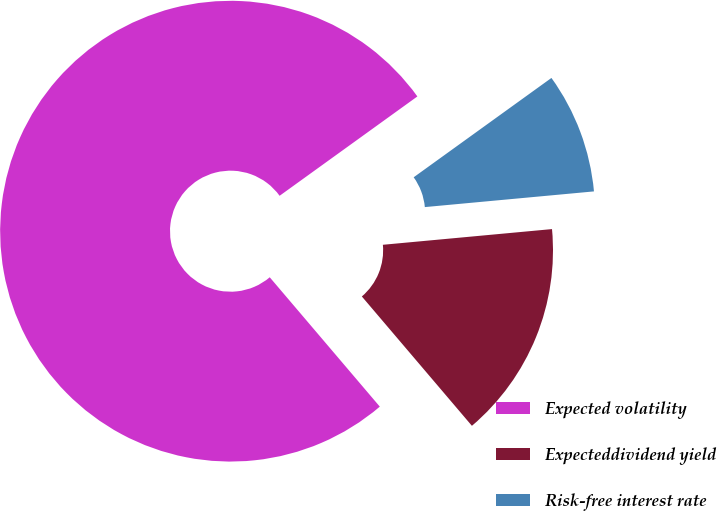Convert chart to OTSL. <chart><loc_0><loc_0><loc_500><loc_500><pie_chart><fcel>Expected volatility<fcel>Expecteddividend yield<fcel>Risk-free interest rate<nl><fcel>76.27%<fcel>15.25%<fcel>8.47%<nl></chart> 